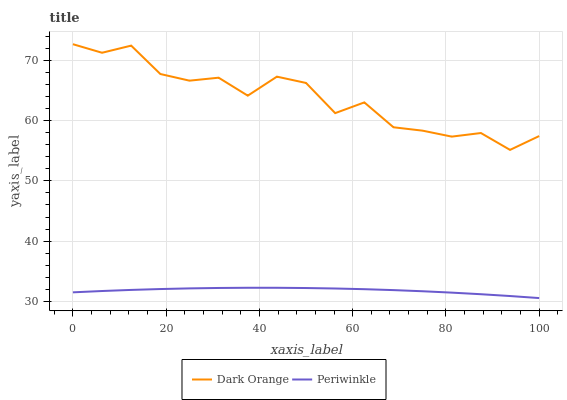Does Periwinkle have the minimum area under the curve?
Answer yes or no. Yes. Does Dark Orange have the maximum area under the curve?
Answer yes or no. Yes. Does Periwinkle have the maximum area under the curve?
Answer yes or no. No. Is Periwinkle the smoothest?
Answer yes or no. Yes. Is Dark Orange the roughest?
Answer yes or no. Yes. Is Periwinkle the roughest?
Answer yes or no. No. Does Periwinkle have the lowest value?
Answer yes or no. Yes. Does Dark Orange have the highest value?
Answer yes or no. Yes. Does Periwinkle have the highest value?
Answer yes or no. No. Is Periwinkle less than Dark Orange?
Answer yes or no. Yes. Is Dark Orange greater than Periwinkle?
Answer yes or no. Yes. Does Periwinkle intersect Dark Orange?
Answer yes or no. No. 